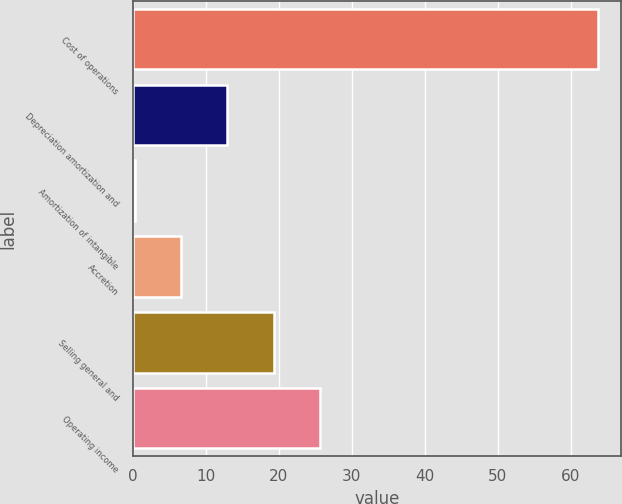<chart> <loc_0><loc_0><loc_500><loc_500><bar_chart><fcel>Cost of operations<fcel>Depreciation amortization and<fcel>Amortization of intangible<fcel>Accretion<fcel>Selling general and<fcel>Operating income<nl><fcel>63.8<fcel>12.92<fcel>0.2<fcel>6.56<fcel>19.28<fcel>25.64<nl></chart> 